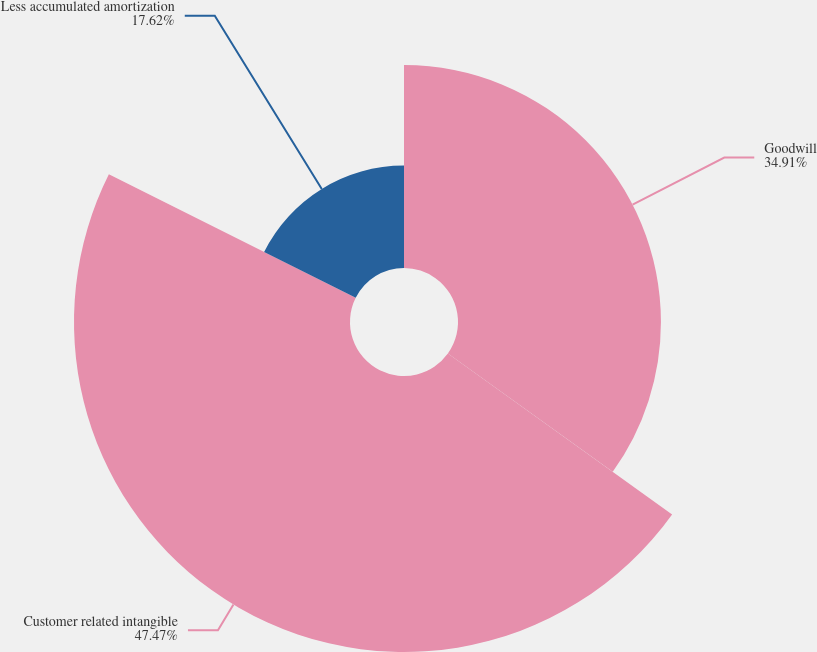Convert chart to OTSL. <chart><loc_0><loc_0><loc_500><loc_500><pie_chart><fcel>Goodwill<fcel>Customer related intangible<fcel>Less accumulated amortization<nl><fcel>34.91%<fcel>47.48%<fcel>17.62%<nl></chart> 